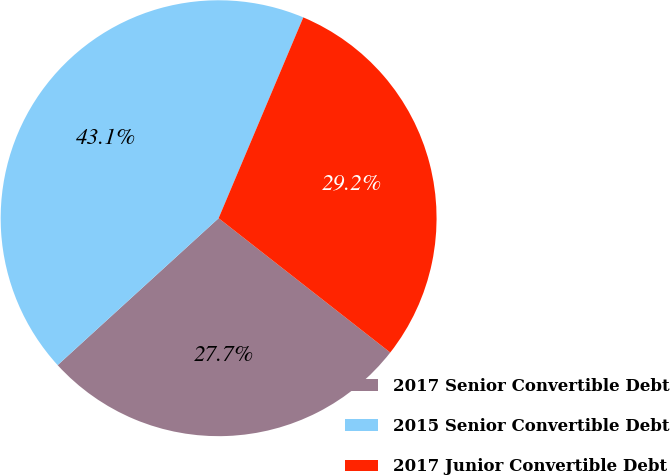Convert chart. <chart><loc_0><loc_0><loc_500><loc_500><pie_chart><fcel>2017 Senior Convertible Debt<fcel>2015 Senior Convertible Debt<fcel>2017 Junior Convertible Debt<nl><fcel>27.66%<fcel>43.13%<fcel>29.22%<nl></chart> 